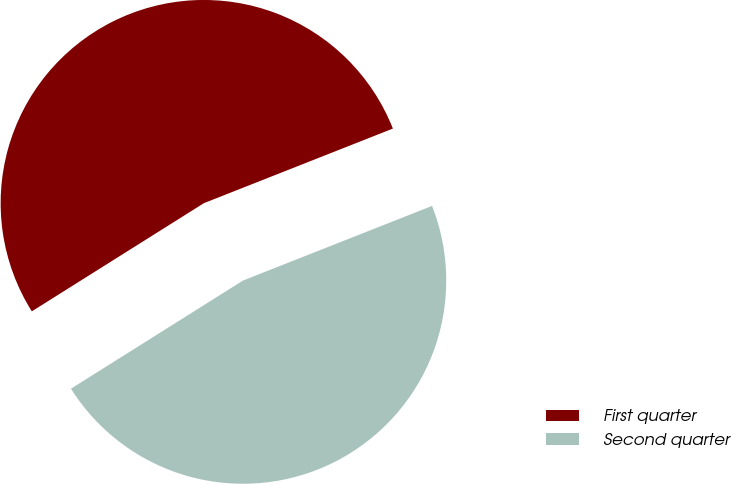<chart> <loc_0><loc_0><loc_500><loc_500><pie_chart><fcel>First quarter<fcel>Second quarter<nl><fcel>52.95%<fcel>47.05%<nl></chart> 